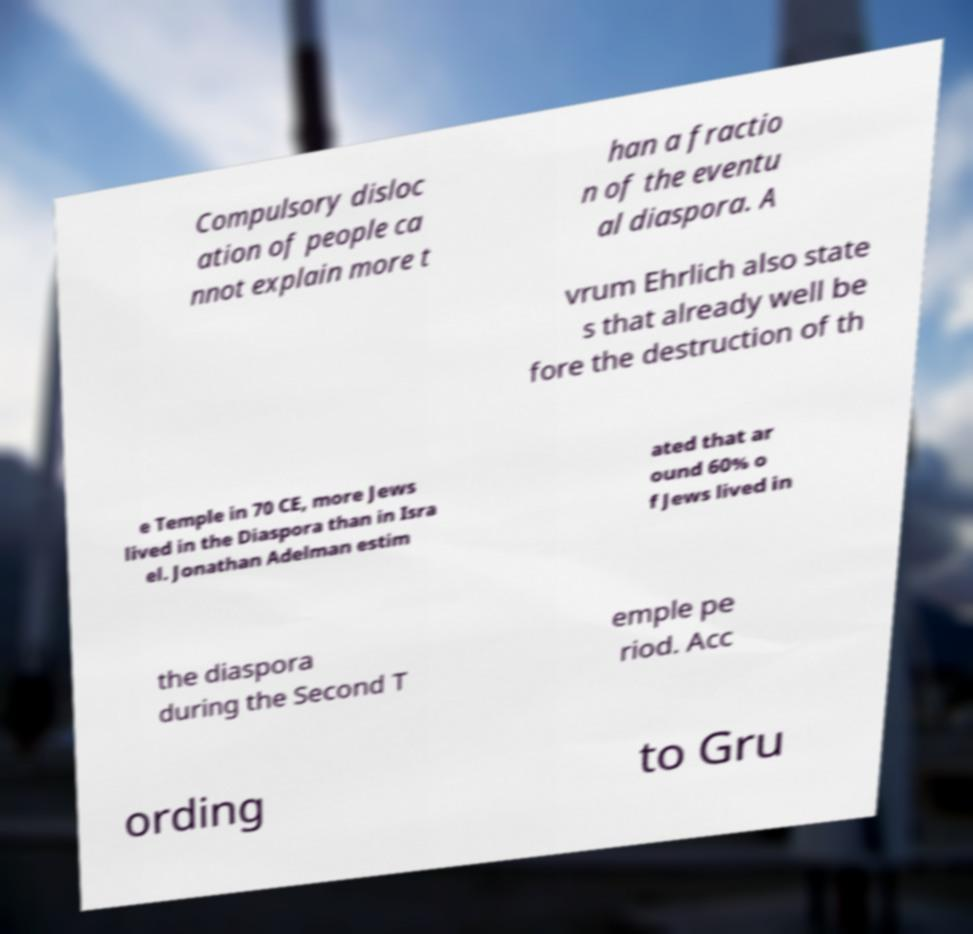There's text embedded in this image that I need extracted. Can you transcribe it verbatim? Compulsory disloc ation of people ca nnot explain more t han a fractio n of the eventu al diaspora. A vrum Ehrlich also state s that already well be fore the destruction of th e Temple in 70 CE, more Jews lived in the Diaspora than in Isra el. Jonathan Adelman estim ated that ar ound 60% o f Jews lived in the diaspora during the Second T emple pe riod. Acc ording to Gru 